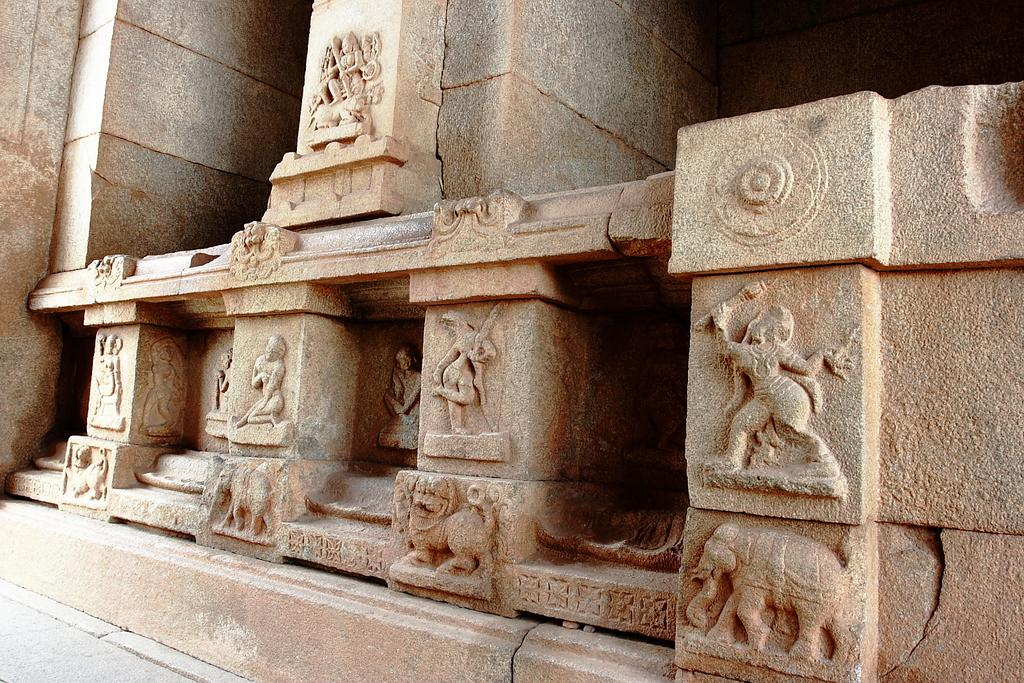What can be seen in the image that represents human-like figures? There are statues in the image. What material are the statues made of? The statues are carved on rocks. What type of doctor is attending to the doll in the image? There is no doll or doctor present in the image; it only features statues carved on rocks. 